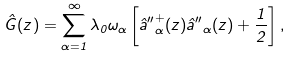Convert formula to latex. <formula><loc_0><loc_0><loc_500><loc_500>\hat { G } ( z ) = \sum _ { \alpha = 1 } ^ { \infty } \lambda _ { 0 } \omega _ { \alpha } \left [ \hat { a } { ^ { \prime \prime } } ^ { + } _ { \alpha } ( z ) \hat { a } { ^ { \prime \prime } } _ { \alpha } ( z ) + \frac { 1 } { 2 } \right ] ,</formula> 